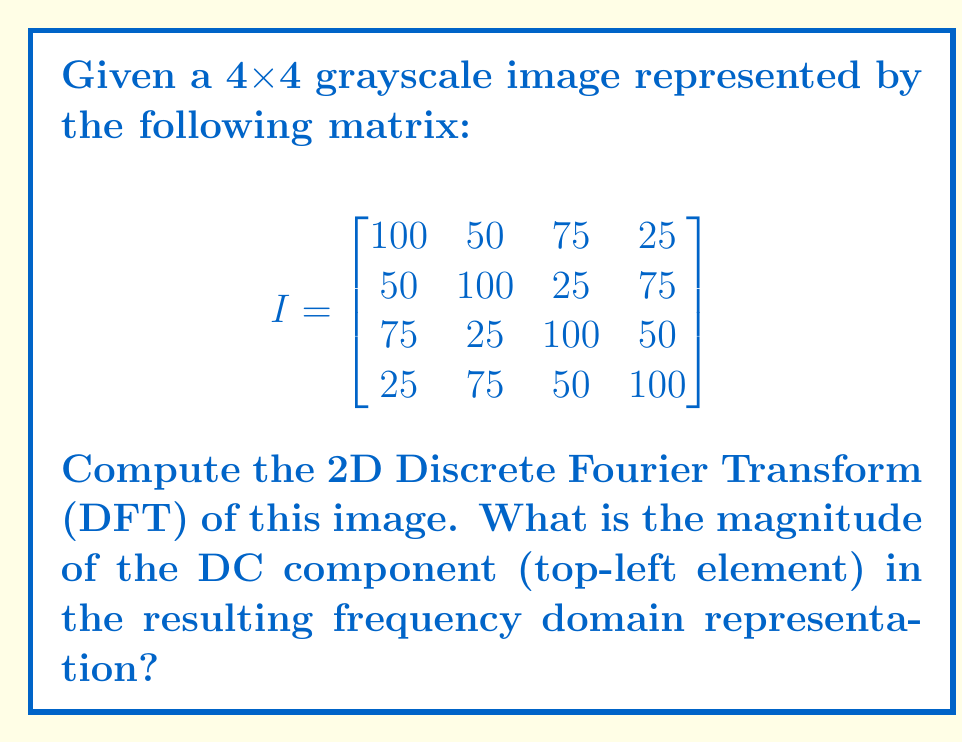Can you answer this question? To compute the 2D DFT of the image, we'll follow these steps:

1) The 2D DFT formula for an MxN image is:

   $$F(u,v) = \sum_{x=0}^{M-1} \sum_{y=0}^{N-1} f(x,y) \cdot e^{-j2\pi(\frac{ux}{M} + \frac{vy}{N})}$$

   where $f(x,y)$ is the image in the spatial domain and $F(u,v)$ is the image in the frequency domain.

2) For a 4x4 image, M = N = 4. The DC component is at $F(0,0)$, which simplifies the formula to:

   $$F(0,0) = \sum_{x=0}^{3} \sum_{y=0}^{3} f(x,y)$$

3) This means the DC component is simply the sum of all pixel values in the image:

   $$F(0,0) = (100 + 50 + 75 + 25) + (50 + 100 + 25 + 75) + (75 + 25 + 100 + 50) + (25 + 75 + 50 + 100)$$

4) Summing up all these values:

   $$F(0,0) = 1000$$

5) The magnitude of a complex number is its absolute value. Since the DC component is real (and positive in this case), its magnitude is simply its value.

Therefore, the magnitude of the DC component is 1000.
Answer: 1000 